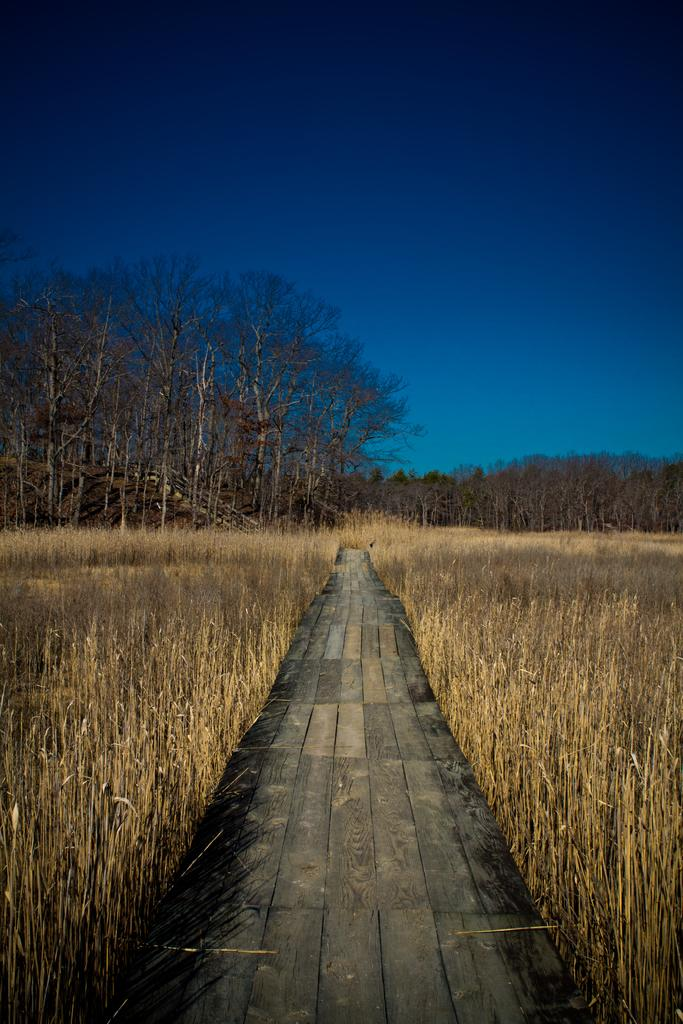What type of structure is in the image? There is a wooden bridge in the image. What can be seen on either side of the bridge? Dry plants are present on either side of the bridge. What is visible in the background of the image? There are trees visible in the background. How would you describe the sky in the image? The sky is clear in the image. What color is the shirt in the image? There is no shirt present in the image. 